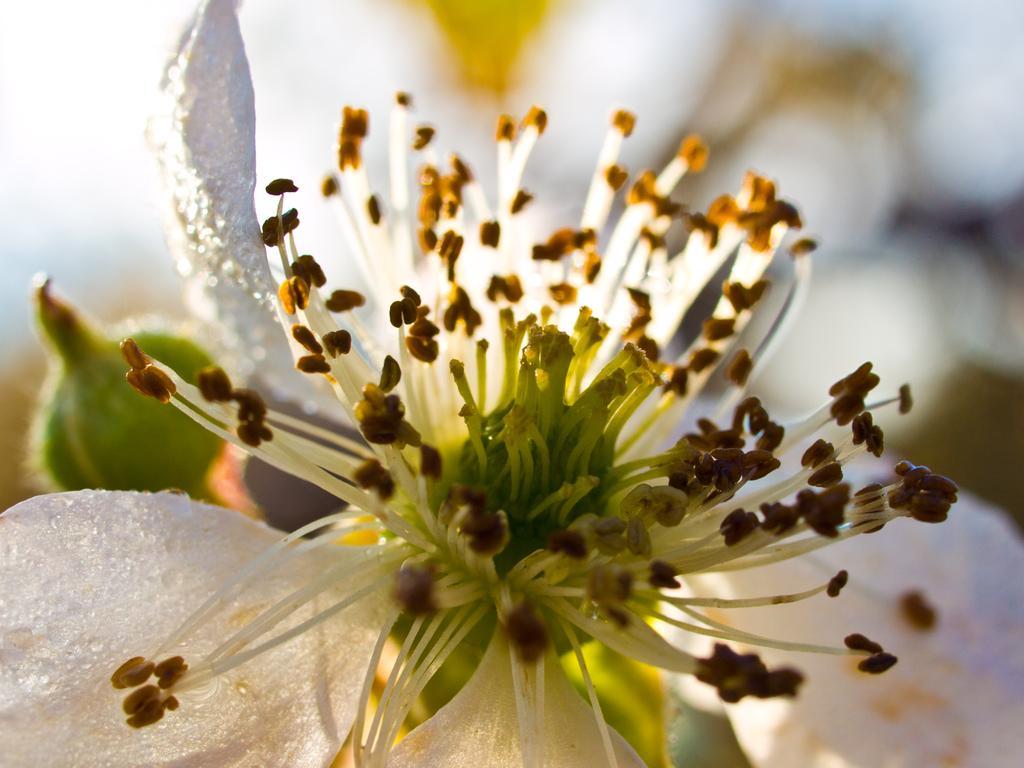Describe this image in one or two sentences. In this picture we can see a flower and bud. In the background of the image it is blue and white. 